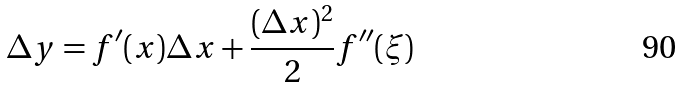Convert formula to latex. <formula><loc_0><loc_0><loc_500><loc_500>\Delta y = f ^ { \prime } ( x ) \Delta x + { \frac { ( \Delta x ) ^ { 2 } } { 2 } } f ^ { \prime \prime } ( \xi )</formula> 